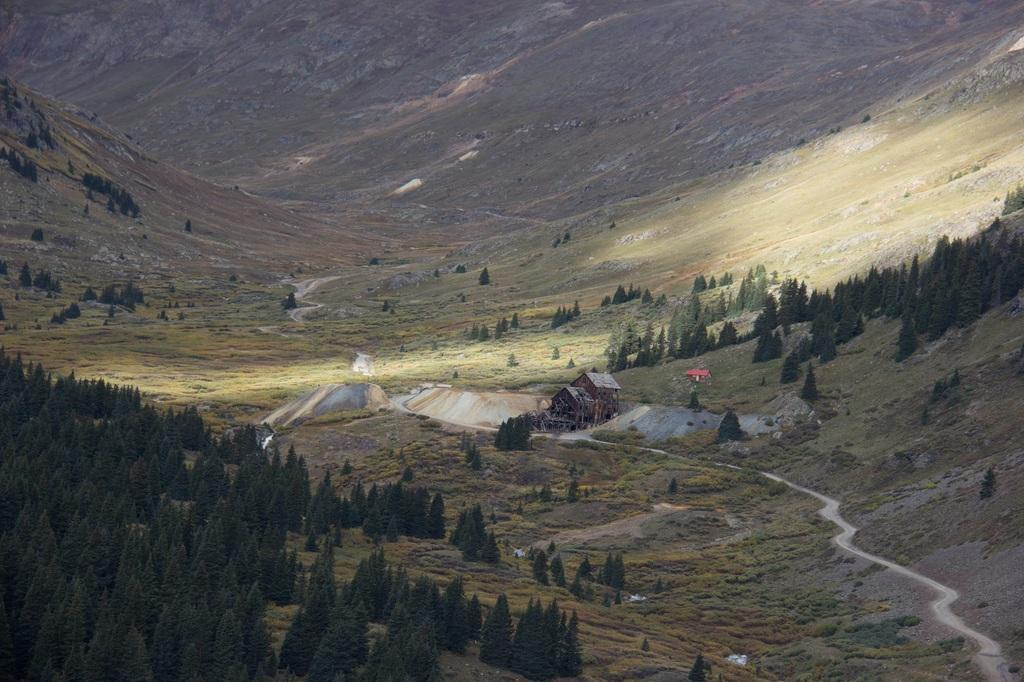Can you describe this image briefly? In this image we can see there are houses and rocks. And there are mountains and trees. 